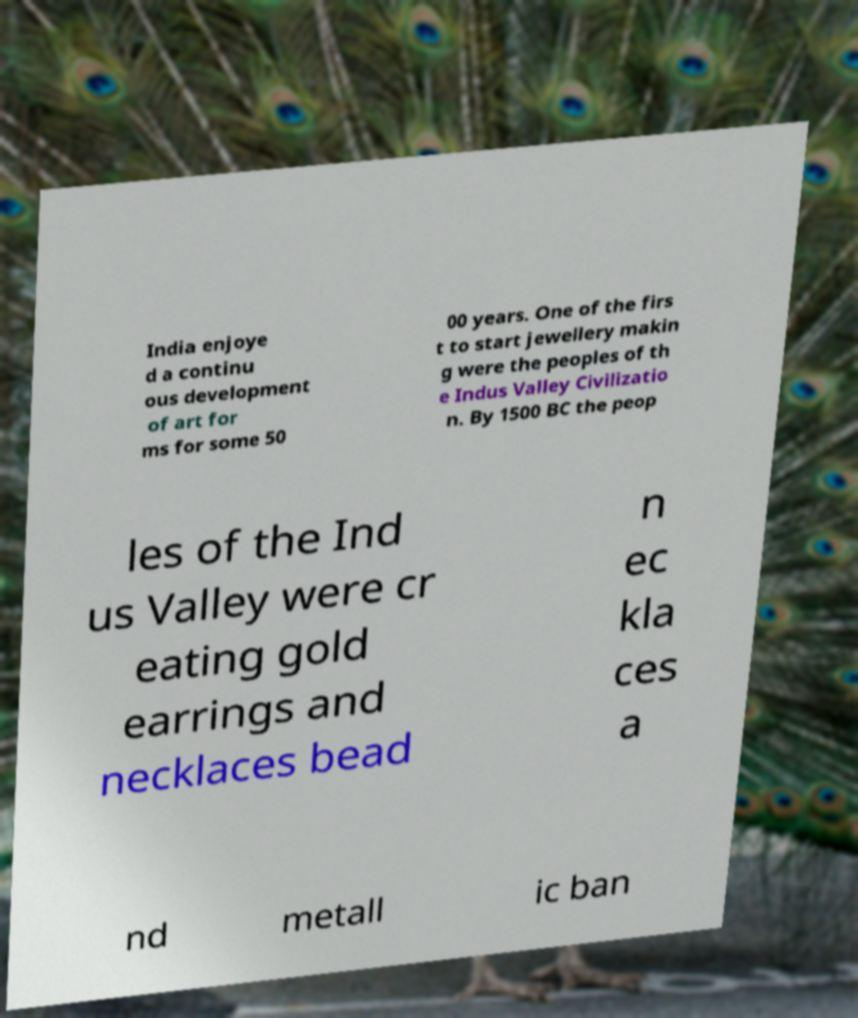Could you assist in decoding the text presented in this image and type it out clearly? India enjoye d a continu ous development of art for ms for some 50 00 years. One of the firs t to start jewellery makin g were the peoples of th e Indus Valley Civilizatio n. By 1500 BC the peop les of the Ind us Valley were cr eating gold earrings and necklaces bead n ec kla ces a nd metall ic ban 